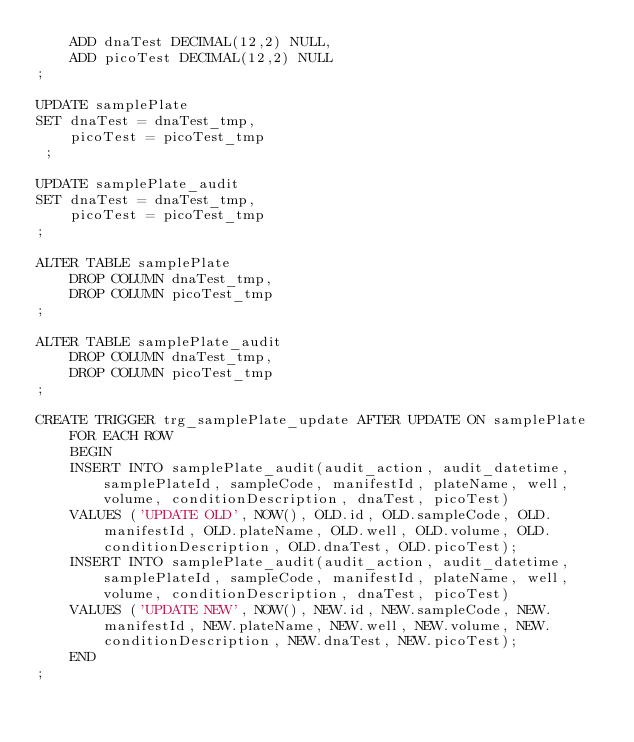<code> <loc_0><loc_0><loc_500><loc_500><_SQL_>    ADD dnaTest DECIMAL(12,2) NULL,
    ADD picoTest DECIMAL(12,2) NULL
;

UPDATE samplePlate
SET dnaTest = dnaTest_tmp,
    picoTest = picoTest_tmp
 ;

UPDATE samplePlate_audit
SET dnaTest = dnaTest_tmp,
    picoTest = picoTest_tmp
;

ALTER TABLE samplePlate
    DROP COLUMN dnaTest_tmp,
    DROP COLUMN picoTest_tmp
;

ALTER TABLE samplePlate_audit
    DROP COLUMN dnaTest_tmp,
    DROP COLUMN picoTest_tmp
;

CREATE TRIGGER trg_samplePlate_update AFTER UPDATE ON samplePlate
    FOR EACH ROW
    BEGIN
		INSERT INTO samplePlate_audit(audit_action, audit_datetime, samplePlateId, sampleCode, manifestId, plateName, well, volume, conditionDescription, dnaTest, picoTest)
		VALUES ('UPDATE OLD', NOW(), OLD.id, OLD.sampleCode, OLD.manifestId, OLD.plateName, OLD.well, OLD.volume, OLD.conditionDescription, OLD.dnaTest, OLD.picoTest);
		INSERT INTO samplePlate_audit(audit_action, audit_datetime, samplePlateId, sampleCode, manifestId, plateName, well, volume, conditionDescription, dnaTest, picoTest)
		VALUES ('UPDATE NEW', NOW(), NEW.id, NEW.sampleCode, NEW.manifestId, NEW.plateName, NEW.well, NEW.volume, NEW.conditionDescription, NEW.dnaTest, NEW.picoTest);
    END
;

</code> 